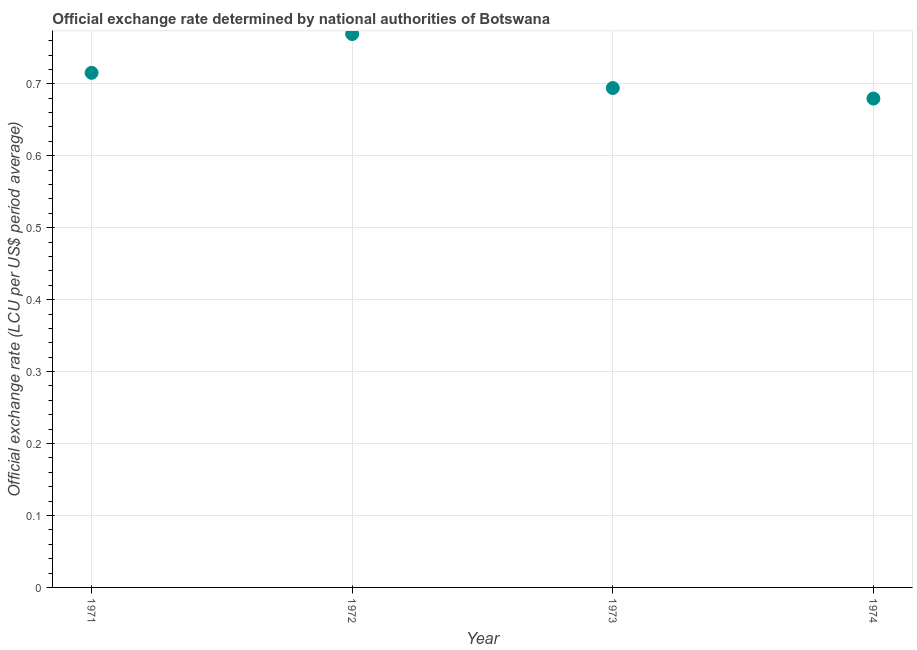What is the official exchange rate in 1971?
Your answer should be compact. 0.72. Across all years, what is the maximum official exchange rate?
Keep it short and to the point. 0.77. Across all years, what is the minimum official exchange rate?
Offer a terse response. 0.68. In which year was the official exchange rate minimum?
Make the answer very short. 1974. What is the sum of the official exchange rate?
Offer a terse response. 2.86. What is the difference between the official exchange rate in 1971 and 1973?
Your response must be concise. 0.02. What is the average official exchange rate per year?
Make the answer very short. 0.71. What is the median official exchange rate?
Offer a terse response. 0.7. In how many years, is the official exchange rate greater than 0.42000000000000004 ?
Give a very brief answer. 4. Do a majority of the years between 1971 and 1974 (inclusive) have official exchange rate greater than 0.36000000000000004 ?
Keep it short and to the point. Yes. What is the ratio of the official exchange rate in 1971 to that in 1974?
Your answer should be very brief. 1.05. Is the official exchange rate in 1971 less than that in 1973?
Your answer should be compact. No. Is the difference between the official exchange rate in 1971 and 1973 greater than the difference between any two years?
Give a very brief answer. No. What is the difference between the highest and the second highest official exchange rate?
Ensure brevity in your answer.  0.05. What is the difference between the highest and the lowest official exchange rate?
Your answer should be compact. 0.09. How many dotlines are there?
Your response must be concise. 1. How many years are there in the graph?
Make the answer very short. 4. What is the difference between two consecutive major ticks on the Y-axis?
Your answer should be very brief. 0.1. Are the values on the major ticks of Y-axis written in scientific E-notation?
Provide a succinct answer. No. Does the graph contain any zero values?
Give a very brief answer. No. What is the title of the graph?
Keep it short and to the point. Official exchange rate determined by national authorities of Botswana. What is the label or title of the Y-axis?
Give a very brief answer. Official exchange rate (LCU per US$ period average). What is the Official exchange rate (LCU per US$ period average) in 1971?
Provide a short and direct response. 0.72. What is the Official exchange rate (LCU per US$ period average) in 1972?
Your answer should be very brief. 0.77. What is the Official exchange rate (LCU per US$ period average) in 1973?
Provide a short and direct response. 0.69. What is the Official exchange rate (LCU per US$ period average) in 1974?
Provide a succinct answer. 0.68. What is the difference between the Official exchange rate (LCU per US$ period average) in 1971 and 1972?
Give a very brief answer. -0.05. What is the difference between the Official exchange rate (LCU per US$ period average) in 1971 and 1973?
Ensure brevity in your answer.  0.02. What is the difference between the Official exchange rate (LCU per US$ period average) in 1971 and 1974?
Make the answer very short. 0.04. What is the difference between the Official exchange rate (LCU per US$ period average) in 1972 and 1973?
Give a very brief answer. 0.08. What is the difference between the Official exchange rate (LCU per US$ period average) in 1972 and 1974?
Your answer should be very brief. 0.09. What is the difference between the Official exchange rate (LCU per US$ period average) in 1973 and 1974?
Keep it short and to the point. 0.01. What is the ratio of the Official exchange rate (LCU per US$ period average) in 1971 to that in 1972?
Keep it short and to the point. 0.93. What is the ratio of the Official exchange rate (LCU per US$ period average) in 1971 to that in 1974?
Provide a short and direct response. 1.05. What is the ratio of the Official exchange rate (LCU per US$ period average) in 1972 to that in 1973?
Make the answer very short. 1.11. What is the ratio of the Official exchange rate (LCU per US$ period average) in 1972 to that in 1974?
Offer a terse response. 1.13. 